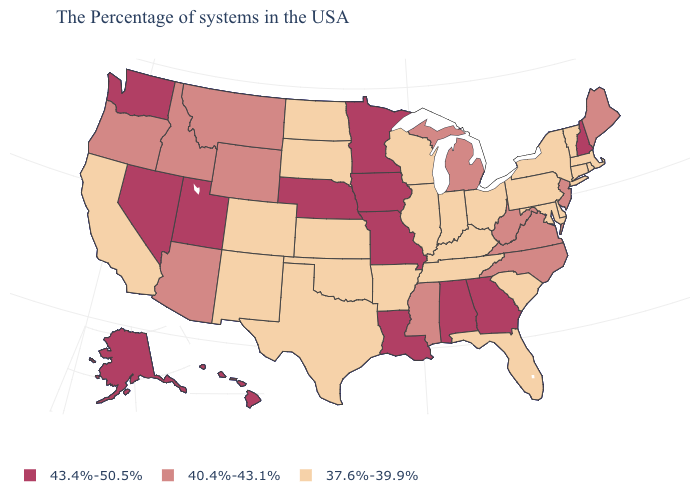What is the value of Louisiana?
Be succinct. 43.4%-50.5%. Which states have the highest value in the USA?
Answer briefly. New Hampshire, Georgia, Alabama, Louisiana, Missouri, Minnesota, Iowa, Nebraska, Utah, Nevada, Washington, Alaska, Hawaii. Does the first symbol in the legend represent the smallest category?
Write a very short answer. No. Which states have the lowest value in the West?
Answer briefly. Colorado, New Mexico, California. Name the states that have a value in the range 37.6%-39.9%?
Give a very brief answer. Massachusetts, Rhode Island, Vermont, Connecticut, New York, Delaware, Maryland, Pennsylvania, South Carolina, Ohio, Florida, Kentucky, Indiana, Tennessee, Wisconsin, Illinois, Arkansas, Kansas, Oklahoma, Texas, South Dakota, North Dakota, Colorado, New Mexico, California. Does Florida have the lowest value in the USA?
Quick response, please. Yes. Name the states that have a value in the range 43.4%-50.5%?
Quick response, please. New Hampshire, Georgia, Alabama, Louisiana, Missouri, Minnesota, Iowa, Nebraska, Utah, Nevada, Washington, Alaska, Hawaii. Does Colorado have the lowest value in the West?
Quick response, please. Yes. What is the lowest value in the USA?
Give a very brief answer. 37.6%-39.9%. Among the states that border Michigan , which have the lowest value?
Quick response, please. Ohio, Indiana, Wisconsin. What is the lowest value in states that border Kentucky?
Keep it brief. 37.6%-39.9%. Does Tennessee have a lower value than Kansas?
Quick response, please. No. What is the lowest value in the USA?
Quick response, please. 37.6%-39.9%. Name the states that have a value in the range 40.4%-43.1%?
Be succinct. Maine, New Jersey, Virginia, North Carolina, West Virginia, Michigan, Mississippi, Wyoming, Montana, Arizona, Idaho, Oregon. What is the value of Louisiana?
Give a very brief answer. 43.4%-50.5%. 